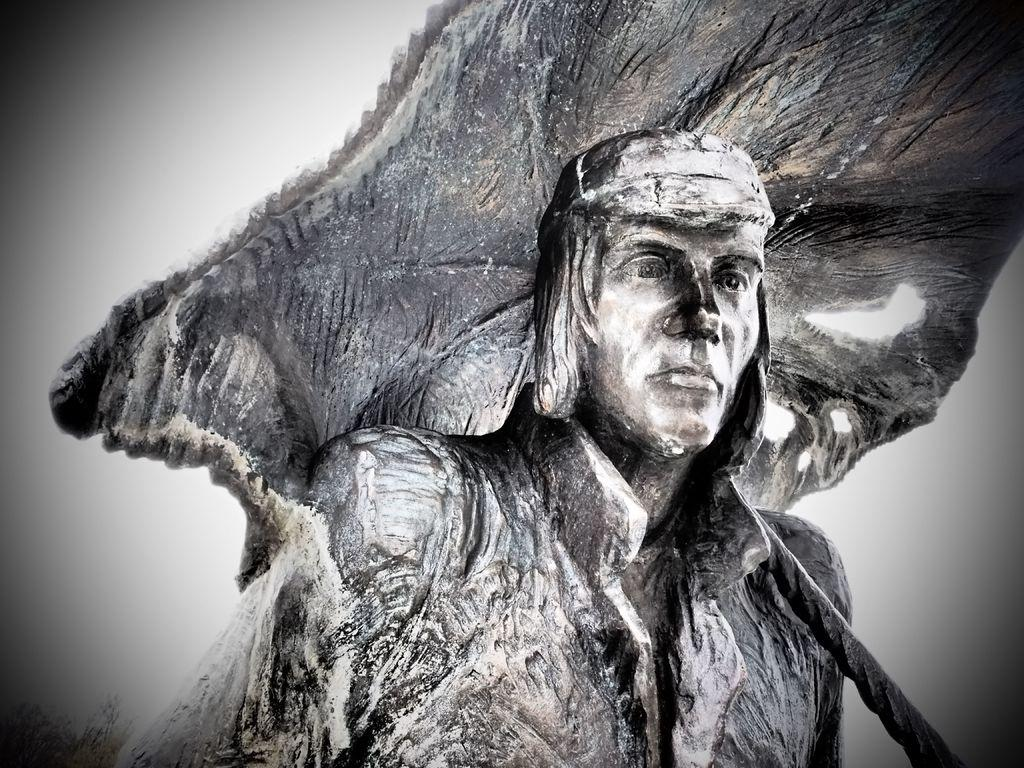What is the main subject in the center of the image? There is a statue in the center of the image. How much money does the beggar in the image have? There is no beggar present in the image; it only features a statue. 